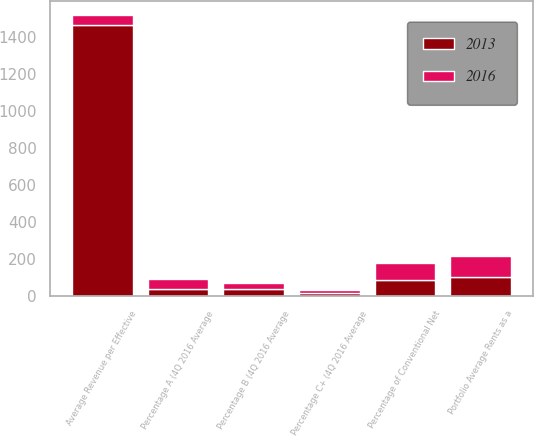Convert chart to OTSL. <chart><loc_0><loc_0><loc_500><loc_500><stacked_bar_chart><ecel><fcel>Percentage of Conventional Net<fcel>Average Revenue per Effective<fcel>Portfolio Average Rents as a<fcel>Percentage A (4Q 2016 Average<fcel>Percentage B (4Q 2016 Average<fcel>Percentage C+ (4Q 2016 Average<nl><fcel>2016<fcel>88<fcel>52<fcel>113<fcel>52<fcel>34<fcel>14<nl><fcel>2013<fcel>88<fcel>1469<fcel>105<fcel>38<fcel>37<fcel>18<nl></chart> 